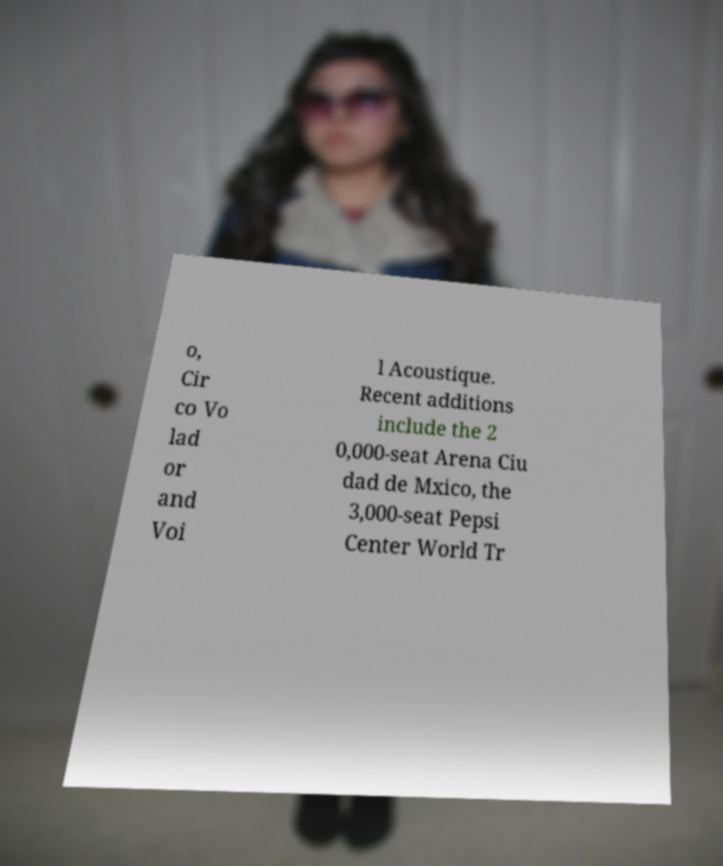What messages or text are displayed in this image? I need them in a readable, typed format. o, Cir co Vo lad or and Voi l Acoustique. Recent additions include the 2 0,000-seat Arena Ciu dad de Mxico, the 3,000-seat Pepsi Center World Tr 